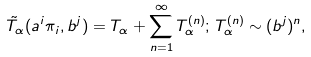<formula> <loc_0><loc_0><loc_500><loc_500>\tilde { T } _ { \alpha } ( a ^ { i } \pi _ { i } , b ^ { j } ) = T _ { \alpha } + \sum _ { n = 1 } ^ { \infty } T _ { \alpha } ^ { ( n ) } ; \, T _ { \alpha } ^ { ( n ) } \sim ( b ^ { j } ) ^ { n } ,</formula> 